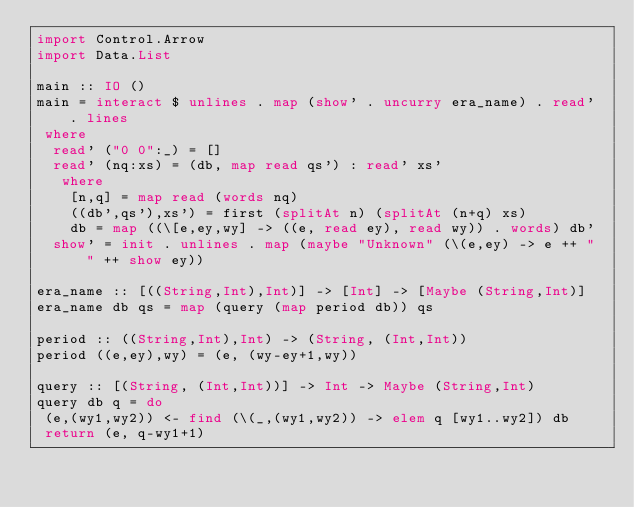<code> <loc_0><loc_0><loc_500><loc_500><_Haskell_>import Control.Arrow
import Data.List

main :: IO ()
main = interact $ unlines . map (show' . uncurry era_name) . read' . lines
 where
  read' ("0 0":_) = []
  read' (nq:xs) = (db, map read qs') : read' xs'
   where
    [n,q] = map read (words nq)
    ((db',qs'),xs') = first (splitAt n) (splitAt (n+q) xs)
    db = map ((\[e,ey,wy] -> ((e, read ey), read wy)) . words) db'
  show' = init . unlines . map (maybe "Unknown" (\(e,ey) -> e ++ " " ++ show ey))

era_name :: [((String,Int),Int)] -> [Int] -> [Maybe (String,Int)]
era_name db qs = map (query (map period db)) qs

period :: ((String,Int),Int) -> (String, (Int,Int))
period ((e,ey),wy) = (e, (wy-ey+1,wy))

query :: [(String, (Int,Int))] -> Int -> Maybe (String,Int)
query db q = do
 (e,(wy1,wy2)) <- find (\(_,(wy1,wy2)) -> elem q [wy1..wy2]) db
 return (e, q-wy1+1)</code> 